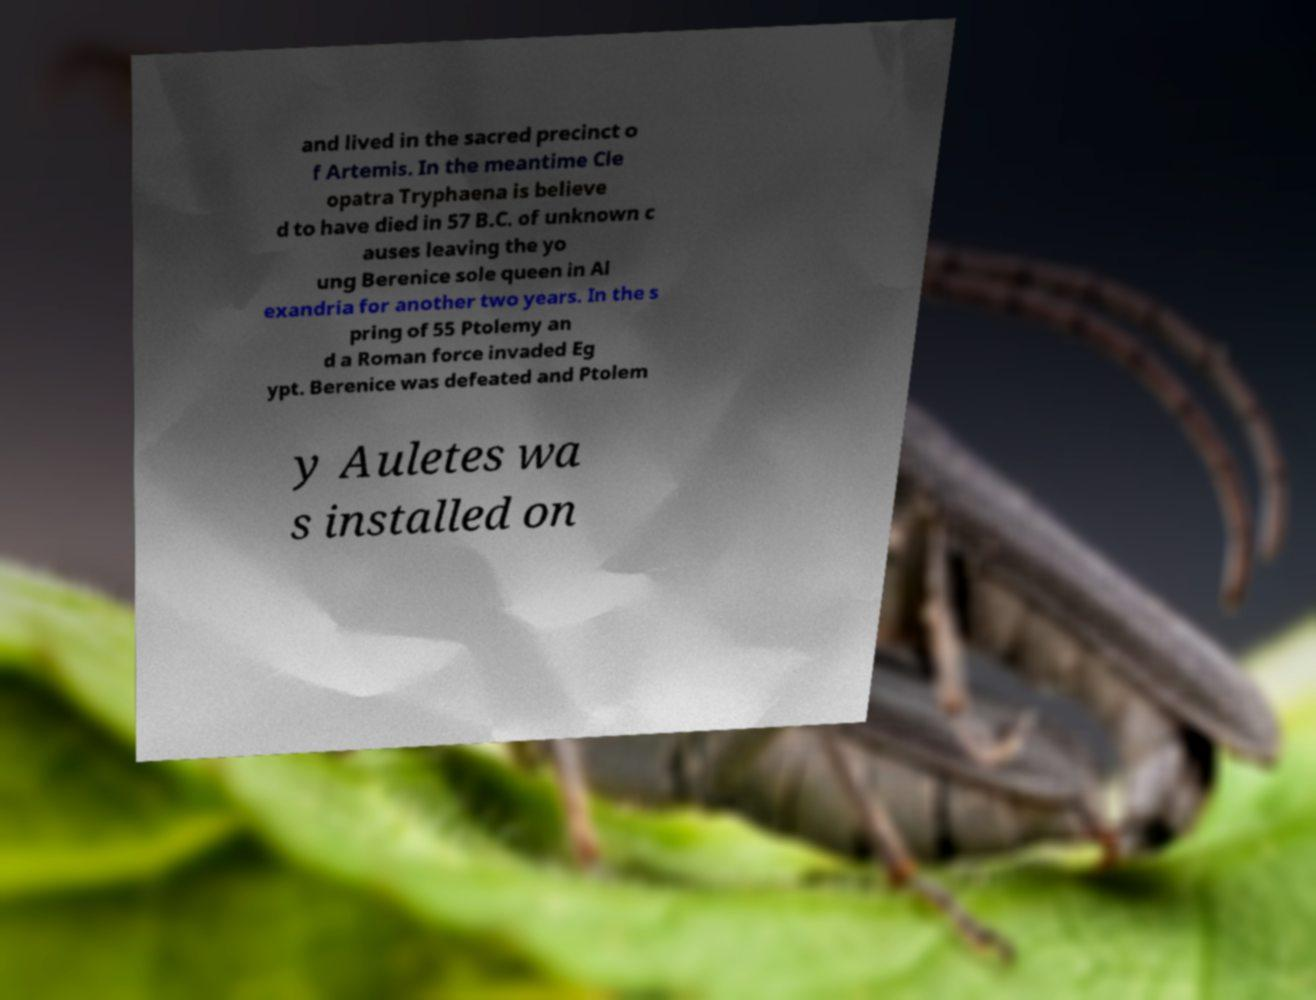Please identify and transcribe the text found in this image. and lived in the sacred precinct o f Artemis. In the meantime Cle opatra Tryphaena is believe d to have died in 57 B.C. of unknown c auses leaving the yo ung Berenice sole queen in Al exandria for another two years. In the s pring of 55 Ptolemy an d a Roman force invaded Eg ypt. Berenice was defeated and Ptolem y Auletes wa s installed on 